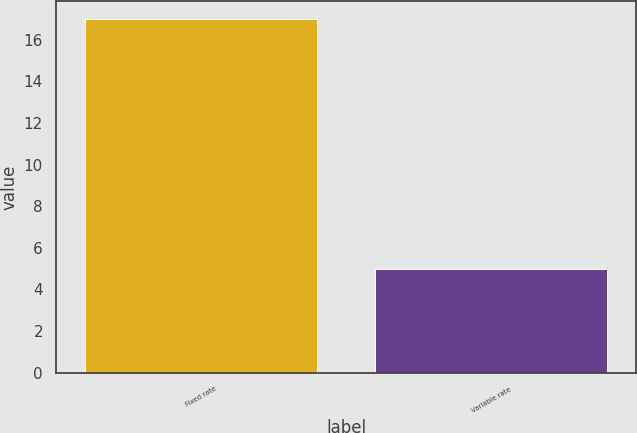<chart> <loc_0><loc_0><loc_500><loc_500><bar_chart><fcel>Fixed rate<fcel>Variable rate<nl><fcel>17<fcel>5<nl></chart> 